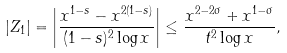Convert formula to latex. <formula><loc_0><loc_0><loc_500><loc_500>| Z _ { 1 } | & = \left | \frac { x ^ { 1 - s } - x ^ { 2 ( 1 - s ) } } { ( 1 - s ) ^ { 2 } \log x } \right | \leq \frac { x ^ { 2 - 2 \sigma } + x ^ { 1 - \sigma } } { t ^ { 2 } \log x } ,</formula> 